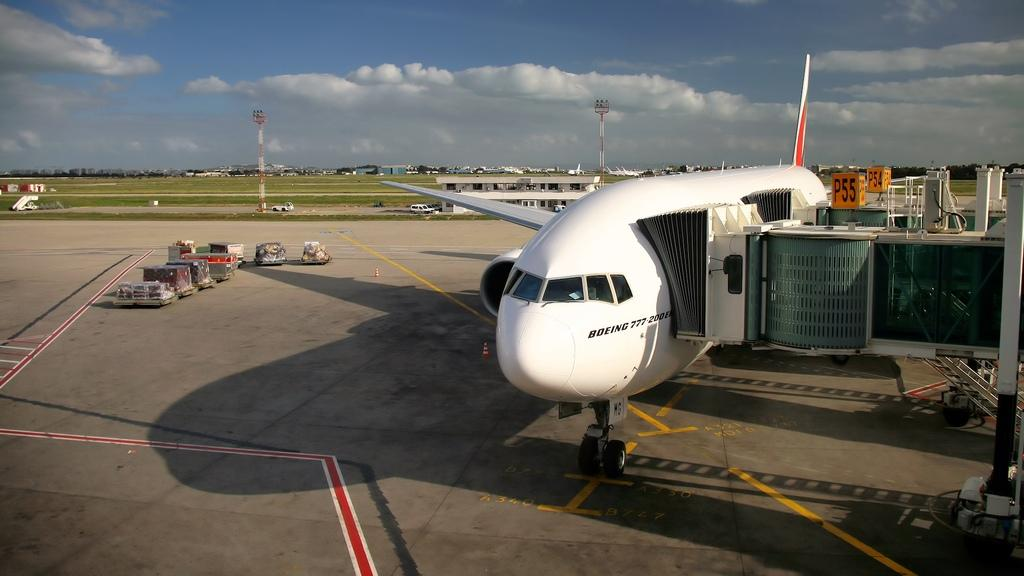What is the main subject of the image? The main subject of the image is an airplane on the surface. What other objects can be seen in the image? There are vehicles and containers in the image. What can be seen in the background of the image? In the background of the image, there are buildings, towers, trees, vehicles, and the sky. What flavor of pig can be seen in the image? There is no pig present in the image, and therefore no flavor can be associated with it. 